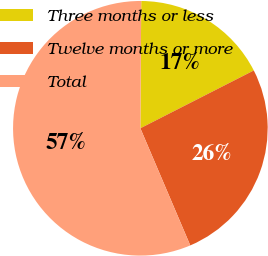Convert chart to OTSL. <chart><loc_0><loc_0><loc_500><loc_500><pie_chart><fcel>Three months or less<fcel>Twelve months or more<fcel>Total<nl><fcel>17.39%<fcel>26.09%<fcel>56.52%<nl></chart> 